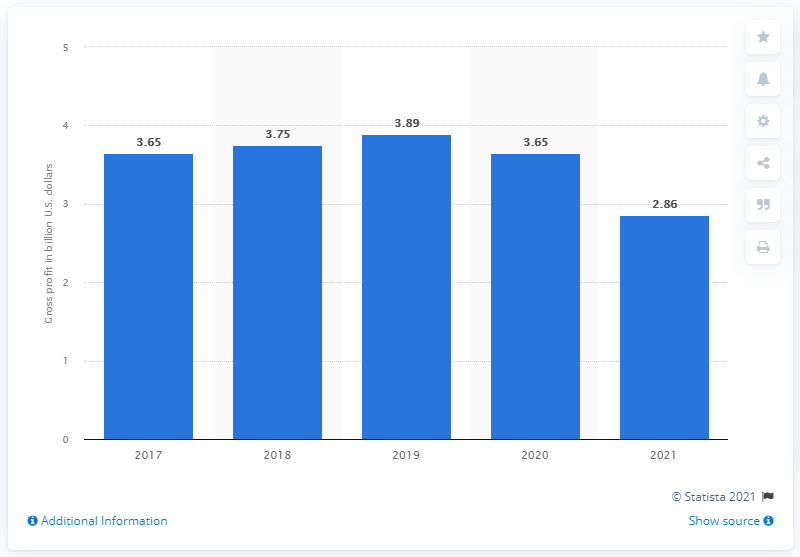Identify some key points in this picture. Polo Ralph Lauren's gross profit in 2021 was 2.86 billion dollars. 